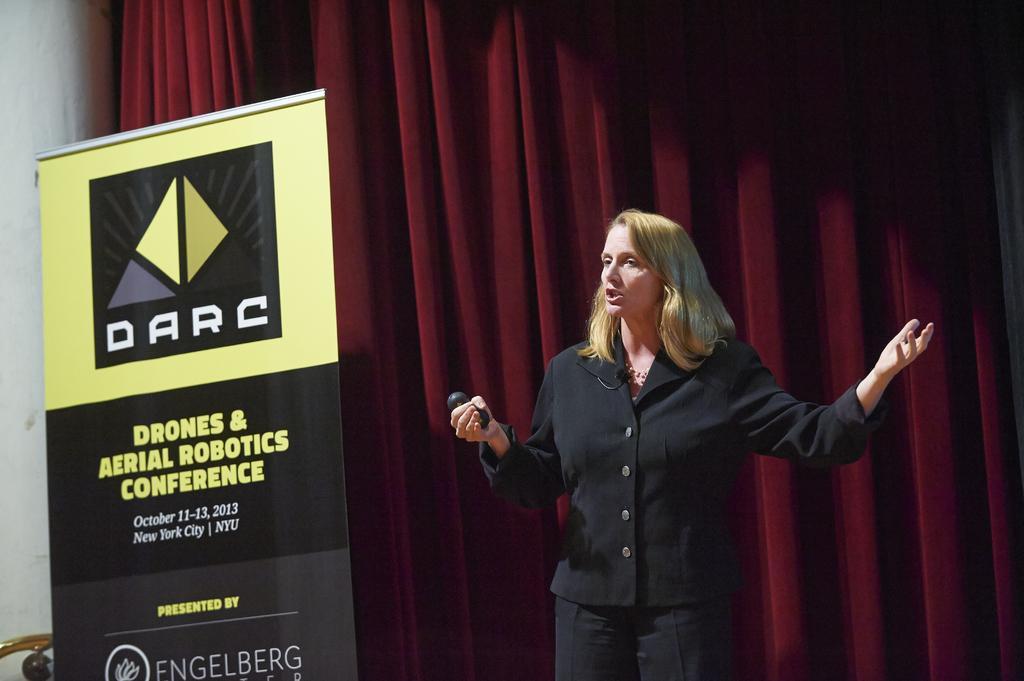In one or two sentences, can you explain what this image depicts? There is a woman wearing black dress is standing and holding an object in her hand and there is a banner which has something written on it behind her and there is a red curtain behind her. 